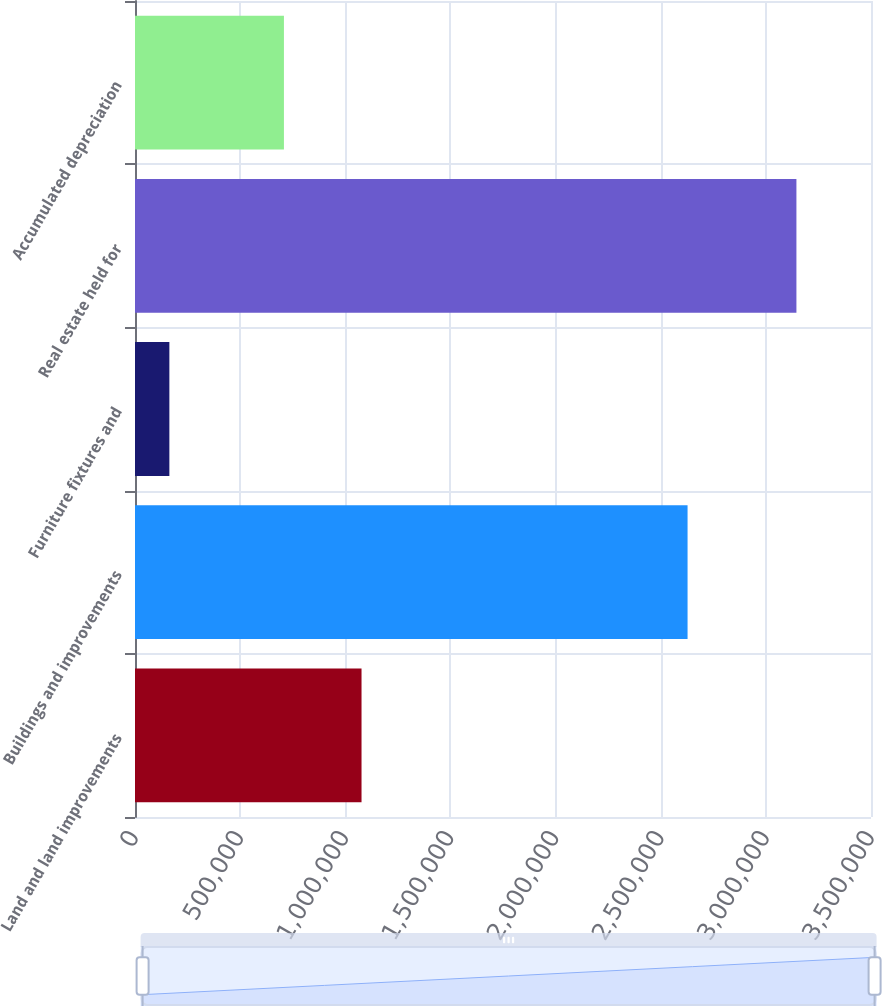<chart> <loc_0><loc_0><loc_500><loc_500><bar_chart><fcel>Land and land improvements<fcel>Buildings and improvements<fcel>Furniture fixtures and<fcel>Real estate held for<fcel>Accumulated depreciation<nl><fcel>1.07725e+06<fcel>2.62767e+06<fcel>163450<fcel>3.14537e+06<fcel>708233<nl></chart> 